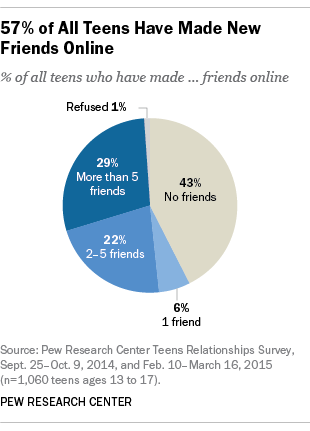Give some essential details in this illustration. The pie graph shows that 6% of the friends have 1 person as their friend. 